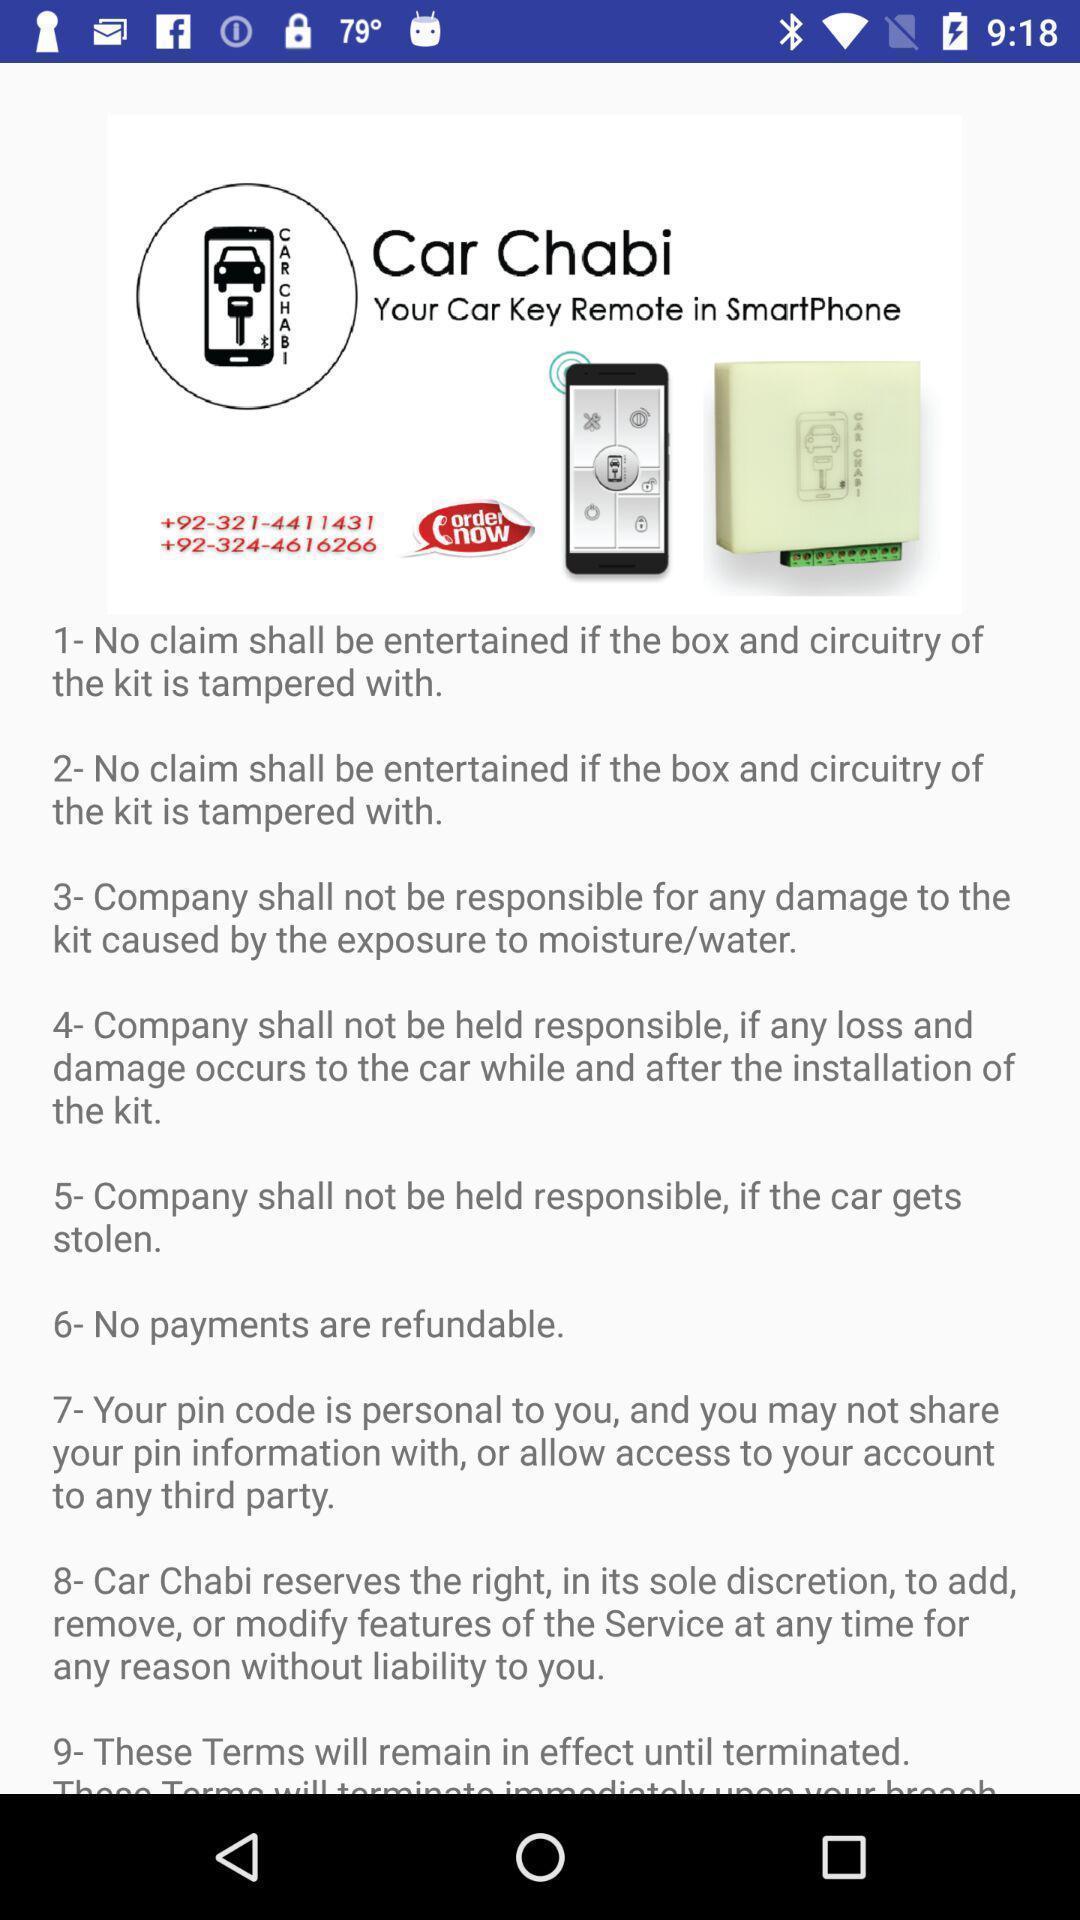Give me a summary of this screen capture. Screen displaying the page of a car rental app. 